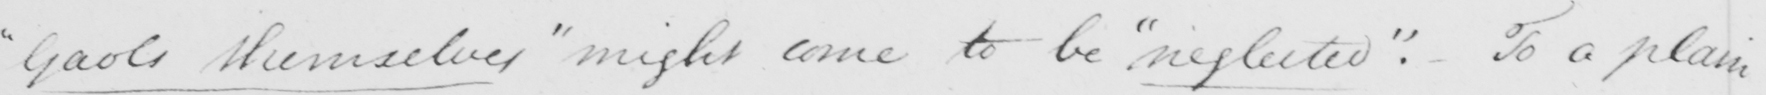What does this handwritten line say? " Gaols themselves "  might come to be  " neglected "  :  To a plain 